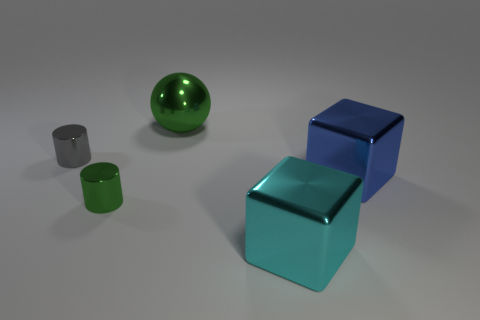Subtract all yellow balls. Subtract all green blocks. How many balls are left? 1 Add 4 purple cubes. How many objects exist? 9 Subtract all blocks. How many objects are left? 3 Add 1 large green balls. How many large green balls exist? 2 Subtract 0 yellow balls. How many objects are left? 5 Subtract all cyan blocks. Subtract all large green metal things. How many objects are left? 3 Add 2 cyan metal things. How many cyan metal things are left? 3 